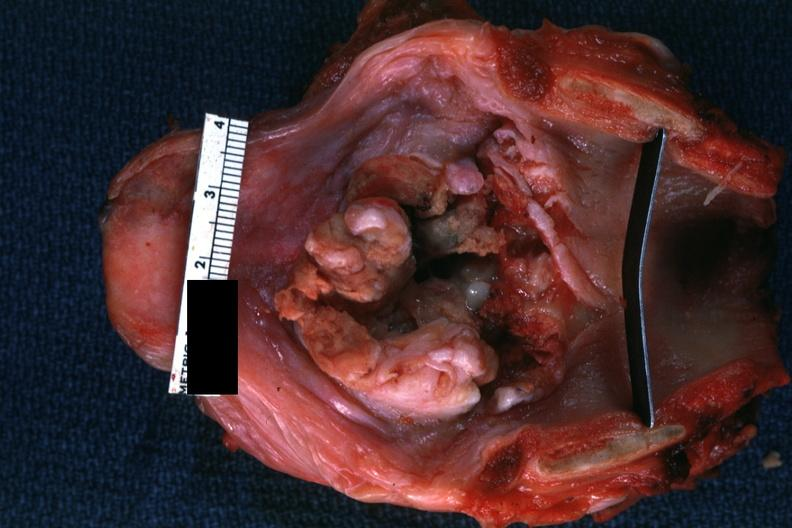where is this?
Answer the question using a single word or phrase. Oral 